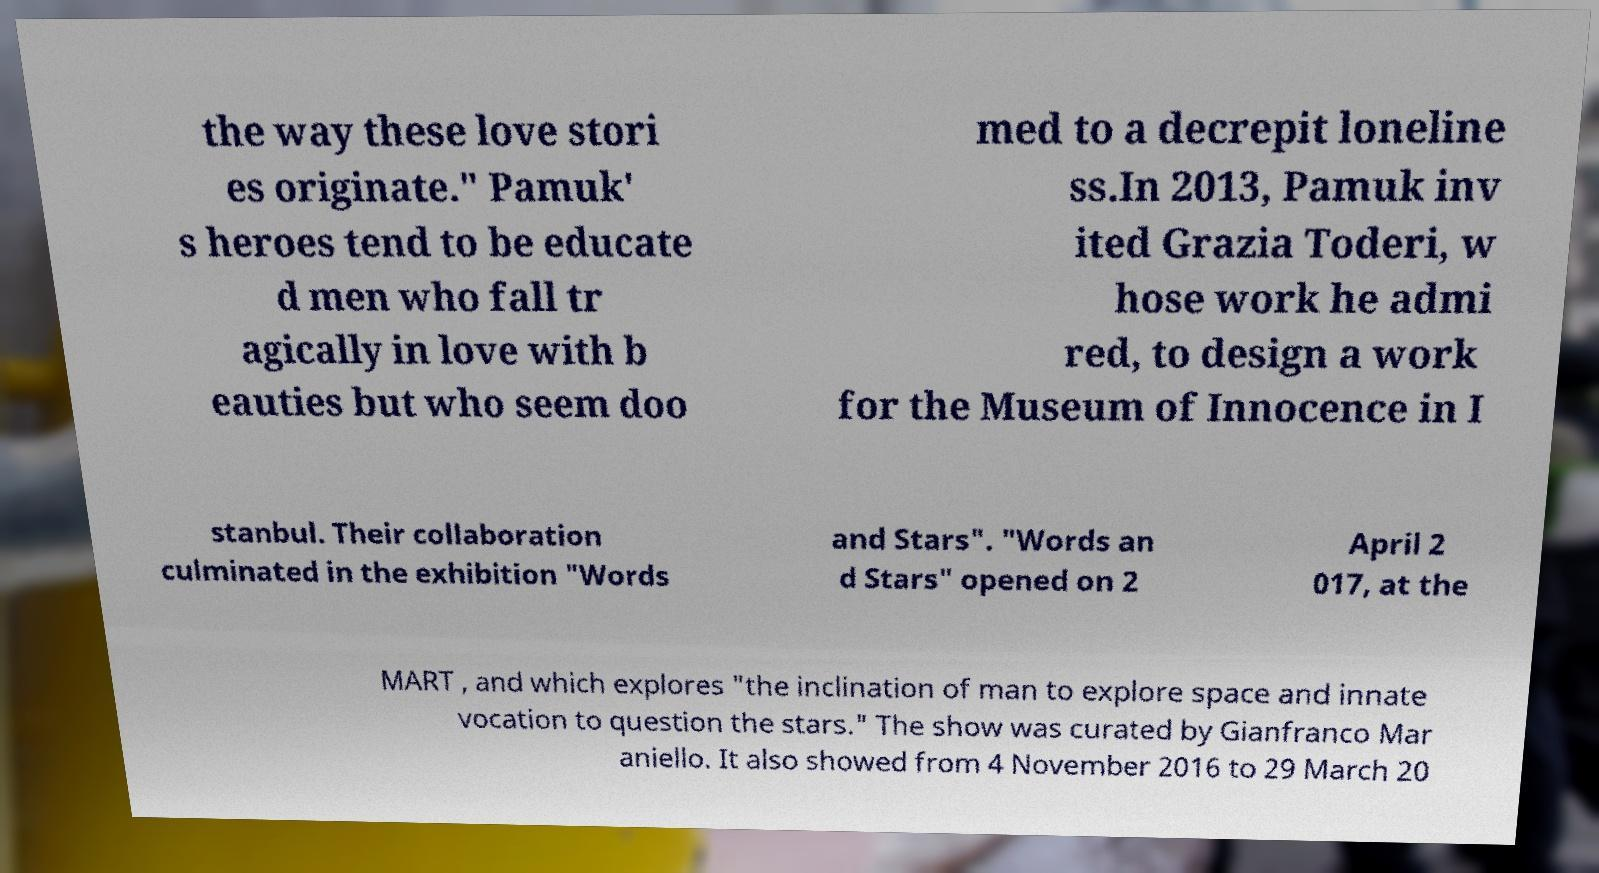I need the written content from this picture converted into text. Can you do that? the way these love stori es originate." Pamuk' s heroes tend to be educate d men who fall tr agically in love with b eauties but who seem doo med to a decrepit loneline ss.In 2013, Pamuk inv ited Grazia Toderi, w hose work he admi red, to design a work for the Museum of Innocence in I stanbul. Their collaboration culminated in the exhibition "Words and Stars". "Words an d Stars" opened on 2 April 2 017, at the MART , and which explores "the inclination of man to explore space and innate vocation to question the stars." The show was curated by Gianfranco Mar aniello. It also showed from 4 November 2016 to 29 March 20 